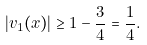Convert formula to latex. <formula><loc_0><loc_0><loc_500><loc_500>| v _ { 1 } ( x ) | \geq 1 - \frac { 3 } { 4 } = \frac { 1 } { 4 } .</formula> 